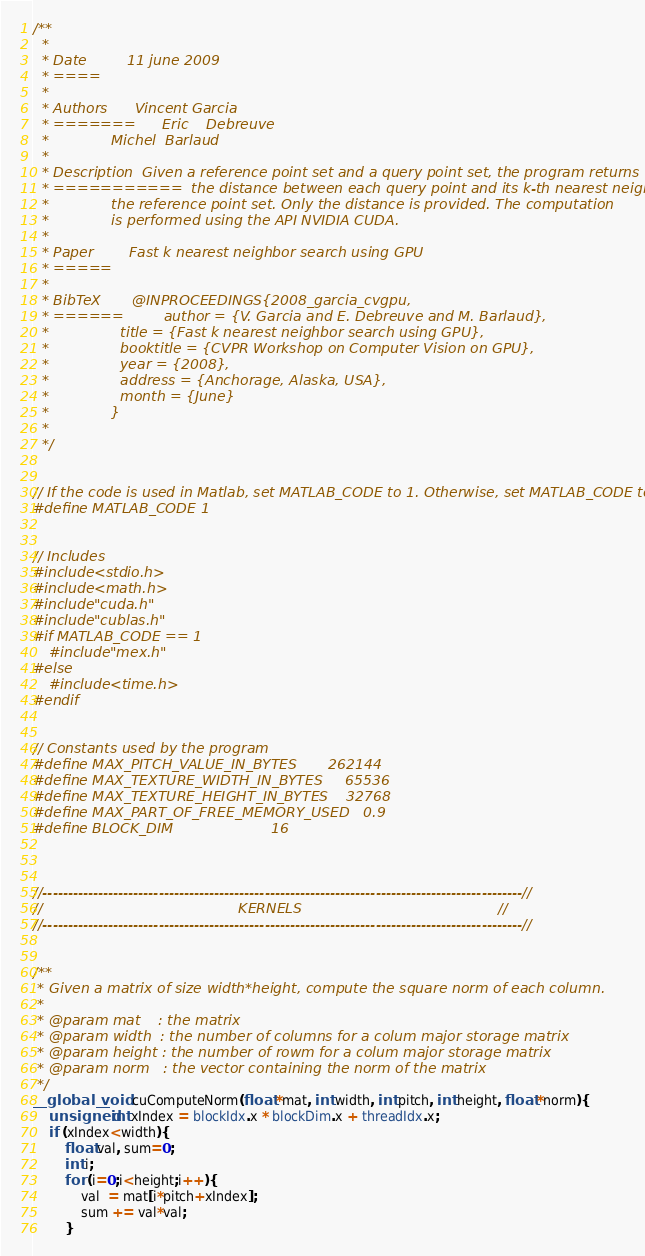Convert code to text. <code><loc_0><loc_0><loc_500><loc_500><_Cuda_>/**
  *
  * Date         11 june 2009
  * ====
  *
  * Authors      Vincent Garcia
  * =======      Eric    Debreuve
  *              Michel  Barlaud
  *
  * Description  Given a reference point set and a query point set, the program returns
  * ===========  the distance between each query point and its k-th nearest neighbor in
  *              the reference point set. Only the distance is provided. The computation
  *              is performed using the API NVIDIA CUDA.
  *
  * Paper        Fast k nearest neighbor search using GPU
  * =====
  *
  * BibTeX       @INPROCEEDINGS{2008_garcia_cvgpu,
  * ======         author = {V. Garcia and E. Debreuve and M. Barlaud},
  *                title = {Fast k nearest neighbor search using GPU},
  *                booktitle = {CVPR Workshop on Computer Vision on GPU},
  *                year = {2008},
  *                address = {Anchorage, Alaska, USA},
  *                month = {June}
  *              }
  *
  */


// If the code is used in Matlab, set MATLAB_CODE to 1. Otherwise, set MATLAB_CODE to 0.
#define MATLAB_CODE 1  


// Includes
#include <stdio.h>
#include <math.h>
#include "cuda.h"
#include "cublas.h"
#if MATLAB_CODE == 1
	#include "mex.h"
#else
	#include <time.h>
#endif


// Constants used by the program
#define MAX_PITCH_VALUE_IN_BYTES       262144
#define MAX_TEXTURE_WIDTH_IN_BYTES     65536
#define MAX_TEXTURE_HEIGHT_IN_BYTES    32768
#define MAX_PART_OF_FREE_MEMORY_USED   0.9
#define BLOCK_DIM                      16



//-----------------------------------------------------------------------------------------------//
//                                            KERNELS                                            //
//-----------------------------------------------------------------------------------------------//


/**
 * Given a matrix of size width*height, compute the square norm of each column.
 *
 * @param mat    : the matrix
 * @param width  : the number of columns for a colum major storage matrix
 * @param height : the number of rowm for a colum major storage matrix
 * @param norm   : the vector containing the norm of the matrix
 */
__global__ void cuComputeNorm(float *mat, int width, int pitch, int height, float *norm){
    unsigned int xIndex = blockIdx.x * blockDim.x + threadIdx.x;
    if (xIndex<width){
        float val, sum=0;
        int i;
        for (i=0;i<height;i++){
            val  = mat[i*pitch+xIndex];
            sum += val*val;
        }</code> 